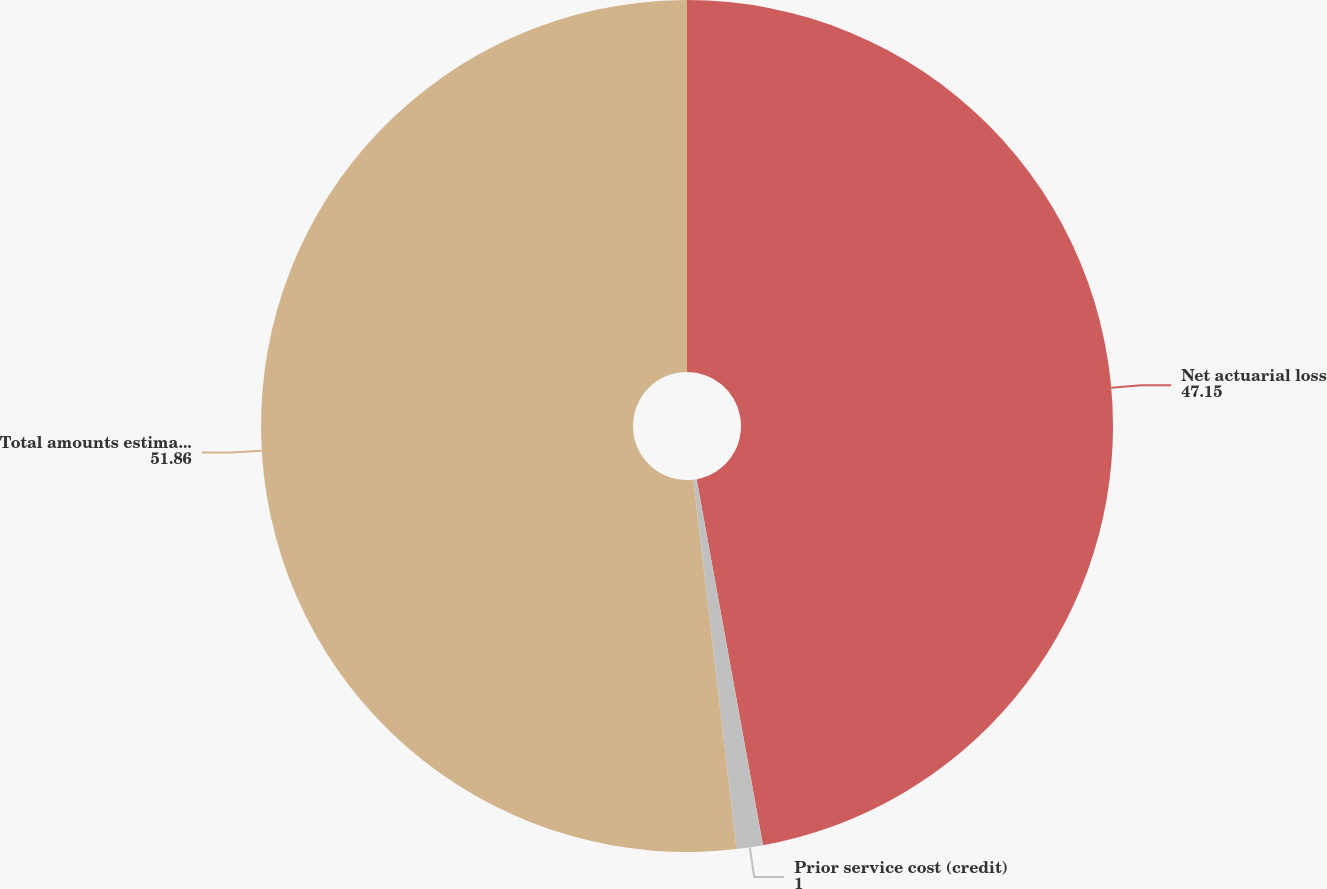Convert chart to OTSL. <chart><loc_0><loc_0><loc_500><loc_500><pie_chart><fcel>Net actuarial loss<fcel>Prior service cost (credit)<fcel>Total amounts estimated to be<nl><fcel>47.15%<fcel>1.0%<fcel>51.86%<nl></chart> 